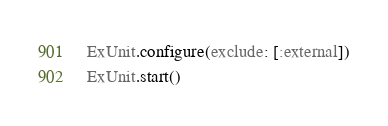<code> <loc_0><loc_0><loc_500><loc_500><_Elixir_>ExUnit.configure(exclude: [:external])
ExUnit.start()
</code> 